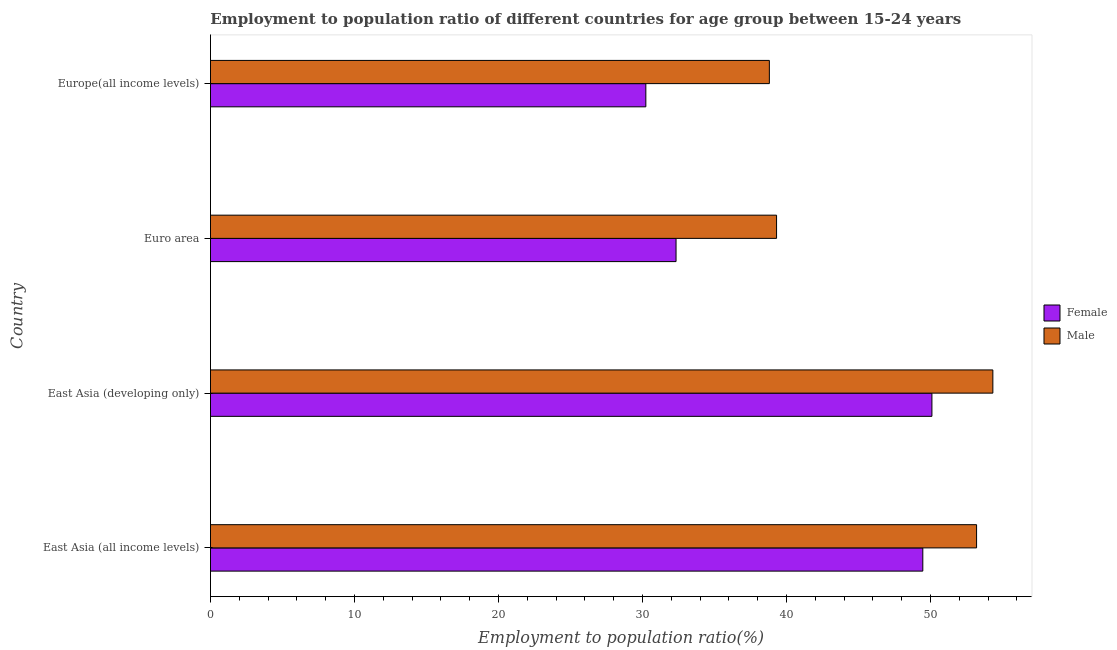How many different coloured bars are there?
Ensure brevity in your answer.  2. Are the number of bars per tick equal to the number of legend labels?
Make the answer very short. Yes. Are the number of bars on each tick of the Y-axis equal?
Provide a short and direct response. Yes. What is the label of the 4th group of bars from the top?
Offer a terse response. East Asia (all income levels). What is the employment to population ratio(female) in Euro area?
Offer a very short reply. 32.33. Across all countries, what is the maximum employment to population ratio(female)?
Your response must be concise. 50.11. Across all countries, what is the minimum employment to population ratio(female)?
Your answer should be very brief. 30.24. In which country was the employment to population ratio(female) maximum?
Offer a terse response. East Asia (developing only). In which country was the employment to population ratio(male) minimum?
Your answer should be very brief. Europe(all income levels). What is the total employment to population ratio(female) in the graph?
Offer a terse response. 162.15. What is the difference between the employment to population ratio(female) in East Asia (all income levels) and that in Euro area?
Provide a succinct answer. 17.14. What is the difference between the employment to population ratio(female) in Euro area and the employment to population ratio(male) in East Asia (developing only)?
Provide a succinct answer. -22. What is the average employment to population ratio(female) per country?
Offer a very short reply. 40.54. What is the difference between the employment to population ratio(male) and employment to population ratio(female) in East Asia (developing only)?
Provide a short and direct response. 4.23. Is the employment to population ratio(female) in East Asia (all income levels) less than that in East Asia (developing only)?
Provide a succinct answer. Yes. What is the difference between the highest and the second highest employment to population ratio(female)?
Make the answer very short. 0.63. What is the difference between the highest and the lowest employment to population ratio(female)?
Your answer should be very brief. 19.87. In how many countries, is the employment to population ratio(female) greater than the average employment to population ratio(female) taken over all countries?
Give a very brief answer. 2. What does the 2nd bar from the bottom in Europe(all income levels) represents?
Keep it short and to the point. Male. How many bars are there?
Provide a succinct answer. 8. How many countries are there in the graph?
Make the answer very short. 4. Does the graph contain any zero values?
Your answer should be compact. No. Does the graph contain grids?
Give a very brief answer. No. Where does the legend appear in the graph?
Your answer should be compact. Center right. What is the title of the graph?
Give a very brief answer. Employment to population ratio of different countries for age group between 15-24 years. Does "Stunting" appear as one of the legend labels in the graph?
Your answer should be very brief. No. What is the label or title of the X-axis?
Provide a succinct answer. Employment to population ratio(%). What is the Employment to population ratio(%) in Female in East Asia (all income levels)?
Keep it short and to the point. 49.47. What is the Employment to population ratio(%) of Male in East Asia (all income levels)?
Provide a succinct answer. 53.21. What is the Employment to population ratio(%) in Female in East Asia (developing only)?
Provide a succinct answer. 50.11. What is the Employment to population ratio(%) in Male in East Asia (developing only)?
Your answer should be compact. 54.34. What is the Employment to population ratio(%) in Female in Euro area?
Ensure brevity in your answer.  32.33. What is the Employment to population ratio(%) of Male in Euro area?
Provide a succinct answer. 39.31. What is the Employment to population ratio(%) of Female in Europe(all income levels)?
Offer a terse response. 30.24. What is the Employment to population ratio(%) in Male in Europe(all income levels)?
Keep it short and to the point. 38.81. Across all countries, what is the maximum Employment to population ratio(%) in Female?
Make the answer very short. 50.11. Across all countries, what is the maximum Employment to population ratio(%) of Male?
Your response must be concise. 54.34. Across all countries, what is the minimum Employment to population ratio(%) in Female?
Your response must be concise. 30.24. Across all countries, what is the minimum Employment to population ratio(%) in Male?
Provide a succinct answer. 38.81. What is the total Employment to population ratio(%) in Female in the graph?
Your answer should be compact. 162.15. What is the total Employment to population ratio(%) of Male in the graph?
Ensure brevity in your answer.  185.67. What is the difference between the Employment to population ratio(%) of Female in East Asia (all income levels) and that in East Asia (developing only)?
Give a very brief answer. -0.63. What is the difference between the Employment to population ratio(%) in Male in East Asia (all income levels) and that in East Asia (developing only)?
Give a very brief answer. -1.13. What is the difference between the Employment to population ratio(%) in Female in East Asia (all income levels) and that in Euro area?
Offer a terse response. 17.14. What is the difference between the Employment to population ratio(%) in Male in East Asia (all income levels) and that in Euro area?
Offer a terse response. 13.89. What is the difference between the Employment to population ratio(%) of Female in East Asia (all income levels) and that in Europe(all income levels)?
Make the answer very short. 19.24. What is the difference between the Employment to population ratio(%) in Male in East Asia (all income levels) and that in Europe(all income levels)?
Your response must be concise. 14.39. What is the difference between the Employment to population ratio(%) in Female in East Asia (developing only) and that in Euro area?
Make the answer very short. 17.77. What is the difference between the Employment to population ratio(%) of Male in East Asia (developing only) and that in Euro area?
Offer a terse response. 15.02. What is the difference between the Employment to population ratio(%) of Female in East Asia (developing only) and that in Europe(all income levels)?
Your answer should be very brief. 19.87. What is the difference between the Employment to population ratio(%) of Male in East Asia (developing only) and that in Europe(all income levels)?
Make the answer very short. 15.52. What is the difference between the Employment to population ratio(%) in Female in Euro area and that in Europe(all income levels)?
Your response must be concise. 2.1. What is the difference between the Employment to population ratio(%) in Male in Euro area and that in Europe(all income levels)?
Your answer should be very brief. 0.5. What is the difference between the Employment to population ratio(%) of Female in East Asia (all income levels) and the Employment to population ratio(%) of Male in East Asia (developing only)?
Ensure brevity in your answer.  -4.86. What is the difference between the Employment to population ratio(%) of Female in East Asia (all income levels) and the Employment to population ratio(%) of Male in Euro area?
Keep it short and to the point. 10.16. What is the difference between the Employment to population ratio(%) of Female in East Asia (all income levels) and the Employment to population ratio(%) of Male in Europe(all income levels)?
Make the answer very short. 10.66. What is the difference between the Employment to population ratio(%) in Female in East Asia (developing only) and the Employment to population ratio(%) in Male in Euro area?
Your answer should be compact. 10.79. What is the difference between the Employment to population ratio(%) of Female in East Asia (developing only) and the Employment to population ratio(%) of Male in Europe(all income levels)?
Provide a succinct answer. 11.29. What is the difference between the Employment to population ratio(%) of Female in Euro area and the Employment to population ratio(%) of Male in Europe(all income levels)?
Offer a terse response. -6.48. What is the average Employment to population ratio(%) of Female per country?
Make the answer very short. 40.54. What is the average Employment to population ratio(%) of Male per country?
Offer a very short reply. 46.42. What is the difference between the Employment to population ratio(%) in Female and Employment to population ratio(%) in Male in East Asia (all income levels)?
Ensure brevity in your answer.  -3.73. What is the difference between the Employment to population ratio(%) in Female and Employment to population ratio(%) in Male in East Asia (developing only)?
Your response must be concise. -4.23. What is the difference between the Employment to population ratio(%) in Female and Employment to population ratio(%) in Male in Euro area?
Provide a short and direct response. -6.98. What is the difference between the Employment to population ratio(%) of Female and Employment to population ratio(%) of Male in Europe(all income levels)?
Your answer should be very brief. -8.58. What is the ratio of the Employment to population ratio(%) of Female in East Asia (all income levels) to that in East Asia (developing only)?
Your response must be concise. 0.99. What is the ratio of the Employment to population ratio(%) in Male in East Asia (all income levels) to that in East Asia (developing only)?
Offer a terse response. 0.98. What is the ratio of the Employment to population ratio(%) of Female in East Asia (all income levels) to that in Euro area?
Provide a succinct answer. 1.53. What is the ratio of the Employment to population ratio(%) of Male in East Asia (all income levels) to that in Euro area?
Offer a terse response. 1.35. What is the ratio of the Employment to population ratio(%) of Female in East Asia (all income levels) to that in Europe(all income levels)?
Your response must be concise. 1.64. What is the ratio of the Employment to population ratio(%) in Male in East Asia (all income levels) to that in Europe(all income levels)?
Provide a short and direct response. 1.37. What is the ratio of the Employment to population ratio(%) in Female in East Asia (developing only) to that in Euro area?
Your answer should be very brief. 1.55. What is the ratio of the Employment to population ratio(%) of Male in East Asia (developing only) to that in Euro area?
Give a very brief answer. 1.38. What is the ratio of the Employment to population ratio(%) in Female in East Asia (developing only) to that in Europe(all income levels)?
Make the answer very short. 1.66. What is the ratio of the Employment to population ratio(%) in Male in East Asia (developing only) to that in Europe(all income levels)?
Your response must be concise. 1.4. What is the ratio of the Employment to population ratio(%) in Female in Euro area to that in Europe(all income levels)?
Make the answer very short. 1.07. What is the ratio of the Employment to population ratio(%) of Male in Euro area to that in Europe(all income levels)?
Your answer should be very brief. 1.01. What is the difference between the highest and the second highest Employment to population ratio(%) of Female?
Ensure brevity in your answer.  0.63. What is the difference between the highest and the second highest Employment to population ratio(%) in Male?
Make the answer very short. 1.13. What is the difference between the highest and the lowest Employment to population ratio(%) in Female?
Keep it short and to the point. 19.87. What is the difference between the highest and the lowest Employment to population ratio(%) in Male?
Your answer should be very brief. 15.52. 